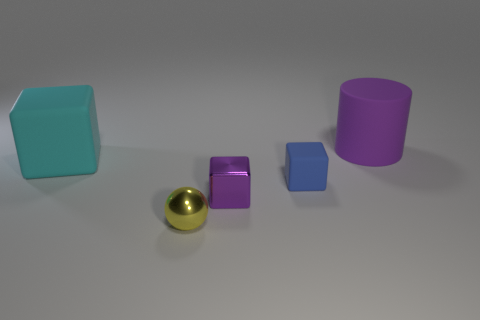Add 5 metallic things. How many objects exist? 10 Subtract all blue rubber cubes. How many cubes are left? 2 Subtract 1 cylinders. How many cylinders are left? 0 Subtract all purple cubes. How many cubes are left? 2 Subtract all cubes. How many objects are left? 2 Subtract all gray cylinders. Subtract all purple blocks. How many cylinders are left? 1 Subtract all cyan spheres. How many cyan cubes are left? 1 Subtract all big matte objects. Subtract all yellow objects. How many objects are left? 2 Add 2 purple cylinders. How many purple cylinders are left? 3 Add 2 small metal objects. How many small metal objects exist? 4 